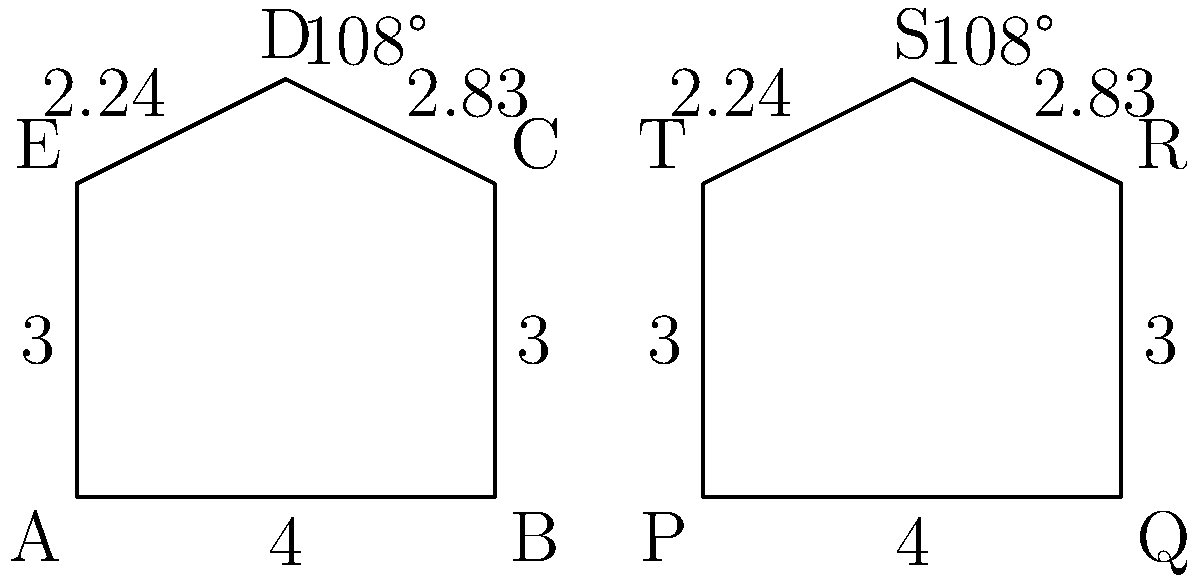As a colleague seeking to improve your communication skills, you've been asked to explain congruence in irregular polygons. Given the two irregular pentagons ABCDE and PQRST shown in the figure, with their side lengths and one angle measurement provided, determine if these polygons are congruent. What additional information, if any, would you need to confidently state that they are congruent? To determine if two irregular polygons are congruent, we need to follow these steps:

1. Compare the number of sides: Both polygons have 5 sides, so this condition is met.

2. Compare the side lengths: All corresponding side lengths are equal:
   AB = PQ = 4
   BC = QR = 3
   CD = RS ≈ 2.83
   DE = ST ≈ 2.24
   EA = TP = 3

3. Compare the angles: We are given that angle D in ABCDE and angle S in PQRST are both 108°.

4. Consider the remaining angles: For two polygons to be congruent, all corresponding angles must be equal. However, we are not given information about the other angles.

5. Apply the Side-Side-Side (SSS) or Side-Angle-Side (SAS) congruence criteria: 
   - SSS requires all sides to be equal (which they are).
   - SAS requires two sides and the included angle to be equal (which we have for one pair of sides and one angle).

Given the information provided, we can conclude that these polygons are likely congruent. However, to be absolutely certain, we would need one of the following:

a) Confirmation that all corresponding angles are equal.
b) One more pair of corresponding equal angles, which would satisfy the Side-Angle-Side-Angle (SASA) criterion for pentagon congruence.

In effective communication, it's important to acknowledge when we have strong evidence but still need additional information for complete certainty.
Answer: Likely congruent, but one more pair of equal corresponding angles needed for certainty. 